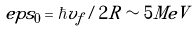<formula> <loc_0><loc_0><loc_500><loc_500>\ e p s _ { 0 } = \hbar { v } _ { f } / 2 R \sim 5 M e V</formula> 